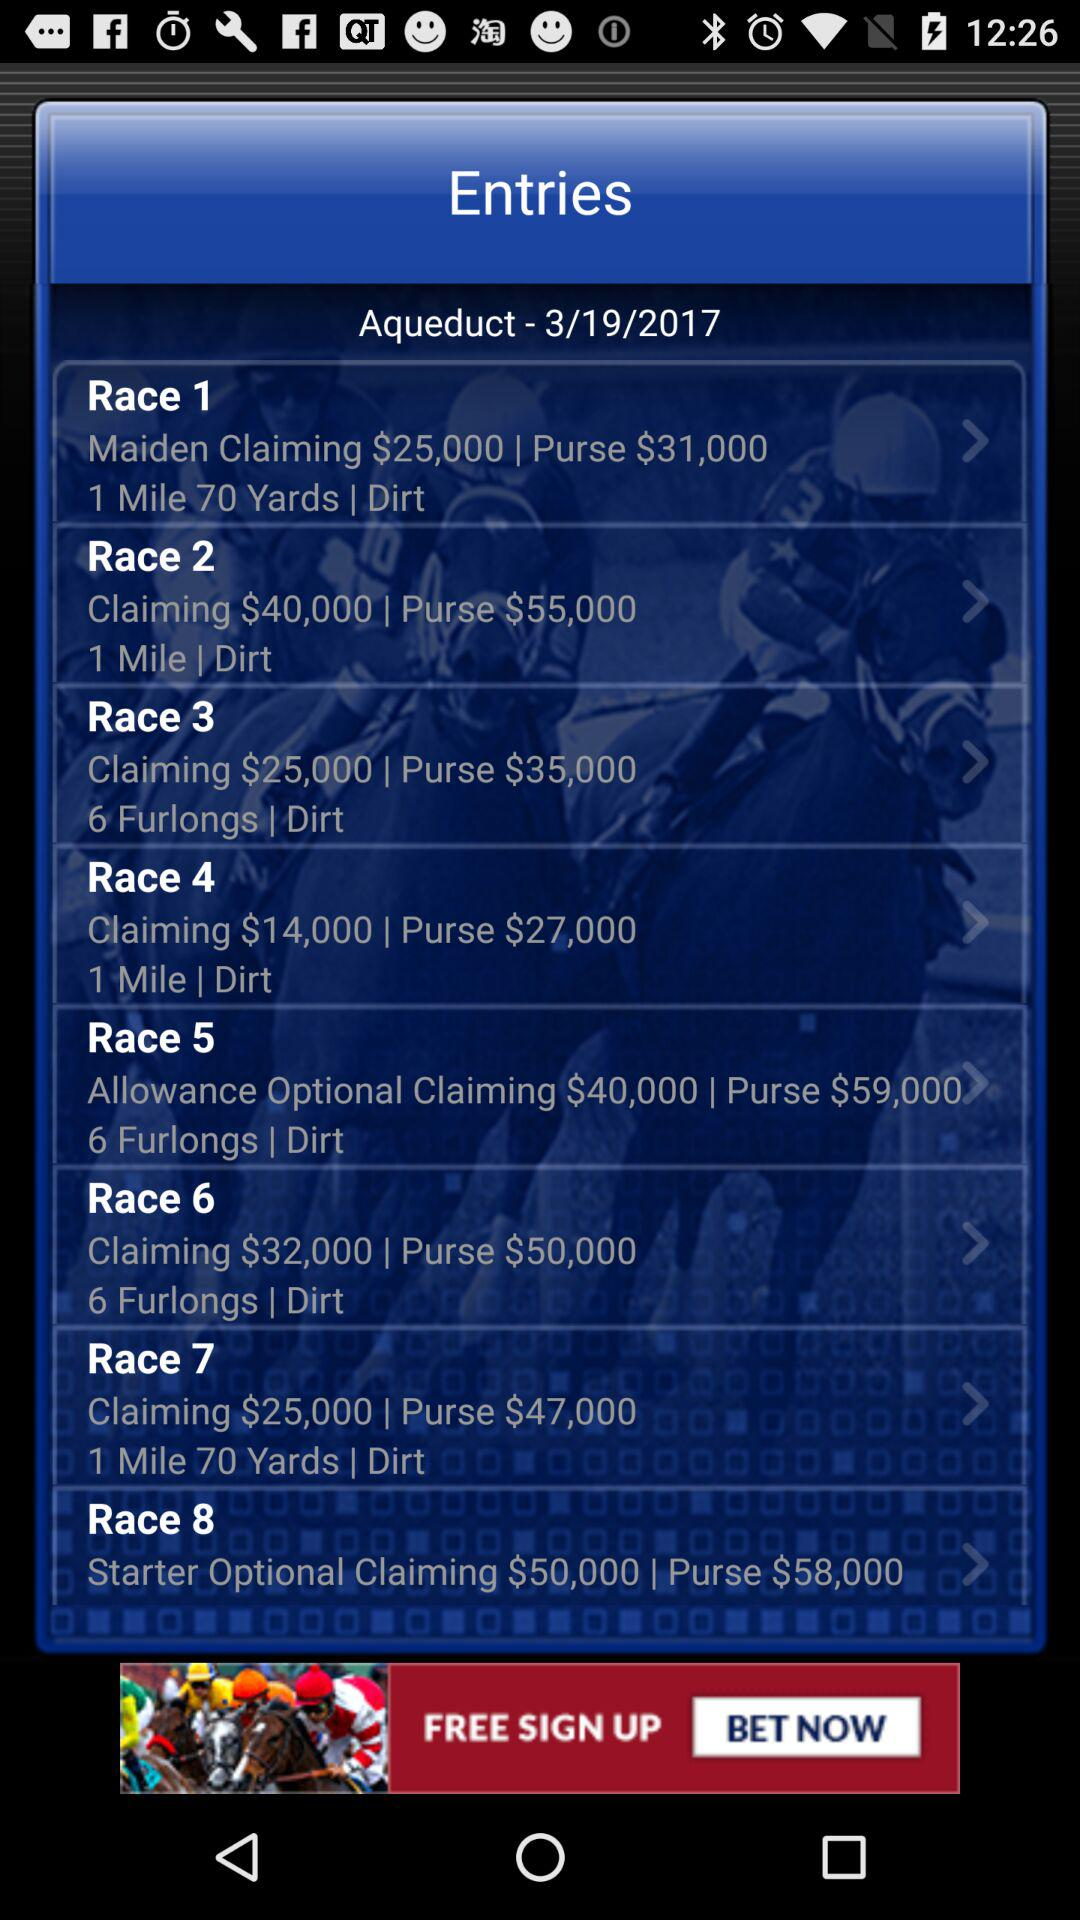What is the starter optional claim amount for "Race 8"? The starter optional claim amount for "Race 8" is $50,000. 